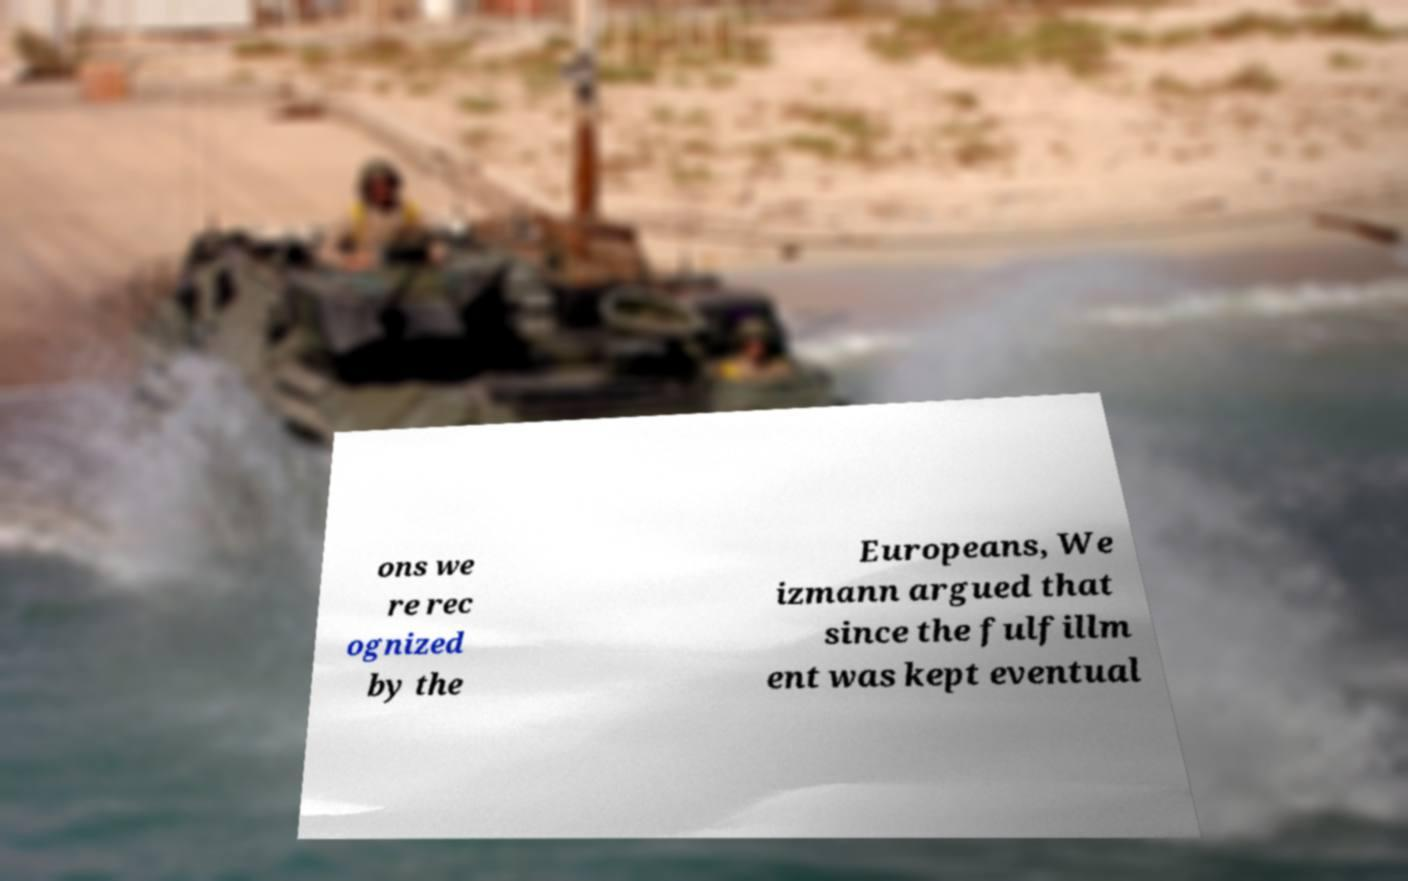Please read and relay the text visible in this image. What does it say? ons we re rec ognized by the Europeans, We izmann argued that since the fulfillm ent was kept eventual 